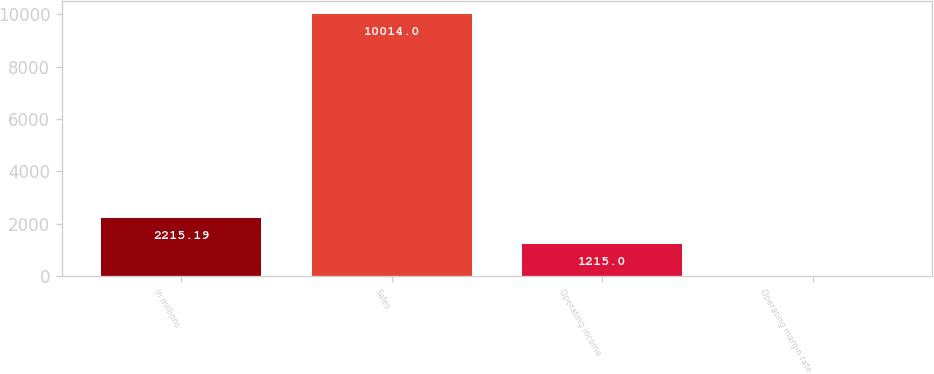<chart> <loc_0><loc_0><loc_500><loc_500><bar_chart><fcel>in millions<fcel>Sales<fcel>Operating income<fcel>Operating margin rate<nl><fcel>2215.19<fcel>10014<fcel>1215<fcel>12.1<nl></chart> 